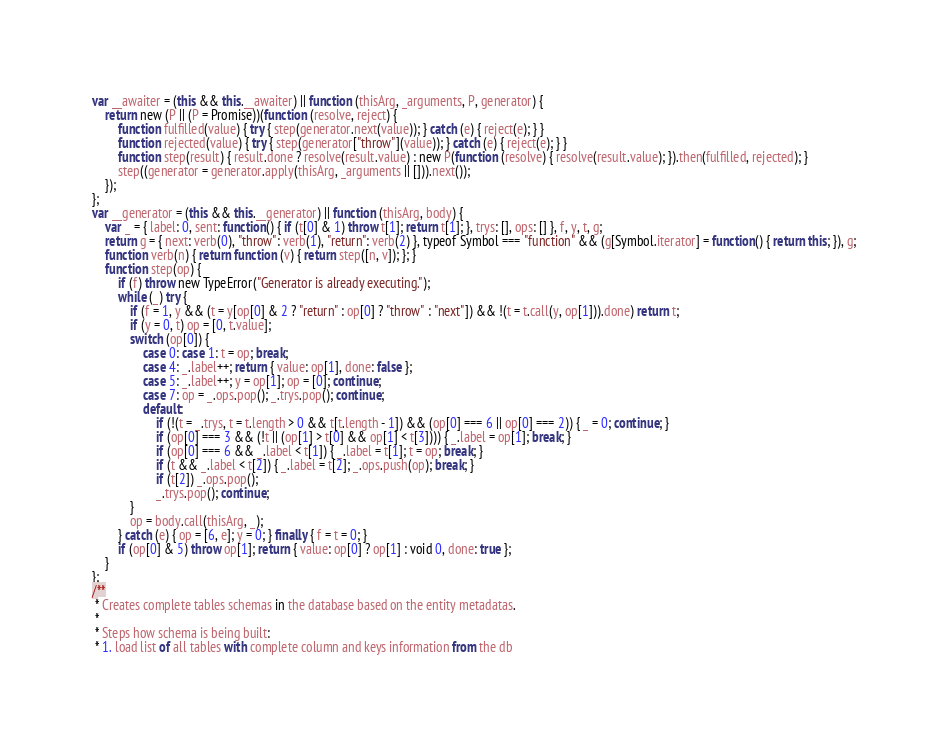Convert code to text. <code><loc_0><loc_0><loc_500><loc_500><_JavaScript_>var __awaiter = (this && this.__awaiter) || function (thisArg, _arguments, P, generator) {
    return new (P || (P = Promise))(function (resolve, reject) {
        function fulfilled(value) { try { step(generator.next(value)); } catch (e) { reject(e); } }
        function rejected(value) { try { step(generator["throw"](value)); } catch (e) { reject(e); } }
        function step(result) { result.done ? resolve(result.value) : new P(function (resolve) { resolve(result.value); }).then(fulfilled, rejected); }
        step((generator = generator.apply(thisArg, _arguments || [])).next());
    });
};
var __generator = (this && this.__generator) || function (thisArg, body) {
    var _ = { label: 0, sent: function() { if (t[0] & 1) throw t[1]; return t[1]; }, trys: [], ops: [] }, f, y, t, g;
    return g = { next: verb(0), "throw": verb(1), "return": verb(2) }, typeof Symbol === "function" && (g[Symbol.iterator] = function() { return this; }), g;
    function verb(n) { return function (v) { return step([n, v]); }; }
    function step(op) {
        if (f) throw new TypeError("Generator is already executing.");
        while (_) try {
            if (f = 1, y && (t = y[op[0] & 2 ? "return" : op[0] ? "throw" : "next"]) && !(t = t.call(y, op[1])).done) return t;
            if (y = 0, t) op = [0, t.value];
            switch (op[0]) {
                case 0: case 1: t = op; break;
                case 4: _.label++; return { value: op[1], done: false };
                case 5: _.label++; y = op[1]; op = [0]; continue;
                case 7: op = _.ops.pop(); _.trys.pop(); continue;
                default:
                    if (!(t = _.trys, t = t.length > 0 && t[t.length - 1]) && (op[0] === 6 || op[0] === 2)) { _ = 0; continue; }
                    if (op[0] === 3 && (!t || (op[1] > t[0] && op[1] < t[3]))) { _.label = op[1]; break; }
                    if (op[0] === 6 && _.label < t[1]) { _.label = t[1]; t = op; break; }
                    if (t && _.label < t[2]) { _.label = t[2]; _.ops.push(op); break; }
                    if (t[2]) _.ops.pop();
                    _.trys.pop(); continue;
            }
            op = body.call(thisArg, _);
        } catch (e) { op = [6, e]; y = 0; } finally { f = t = 0; }
        if (op[0] & 5) throw op[1]; return { value: op[0] ? op[1] : void 0, done: true };
    }
};
/**
 * Creates complete tables schemas in the database based on the entity metadatas.
 *
 * Steps how schema is being built:
 * 1. load list of all tables with complete column and keys information from the db</code> 